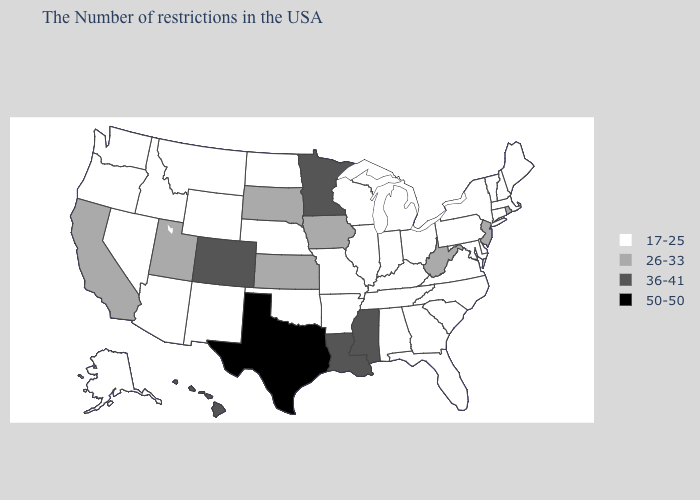Name the states that have a value in the range 36-41?
Give a very brief answer. Mississippi, Louisiana, Minnesota, Colorado, Hawaii. Among the states that border Maine , which have the lowest value?
Write a very short answer. New Hampshire. What is the value of Michigan?
Concise answer only. 17-25. Does North Carolina have the lowest value in the South?
Be succinct. Yes. What is the value of Hawaii?
Answer briefly. 36-41. Which states hav the highest value in the South?
Be succinct. Texas. Name the states that have a value in the range 50-50?
Concise answer only. Texas. Does Texas have the highest value in the South?
Quick response, please. Yes. Name the states that have a value in the range 36-41?
Concise answer only. Mississippi, Louisiana, Minnesota, Colorado, Hawaii. Does Missouri have the same value as Rhode Island?
Concise answer only. No. Does West Virginia have the highest value in the USA?
Be succinct. No. What is the value of Kansas?
Give a very brief answer. 26-33. Does the map have missing data?
Answer briefly. No. What is the value of Minnesota?
Answer briefly. 36-41. What is the value of Massachusetts?
Write a very short answer. 17-25. 